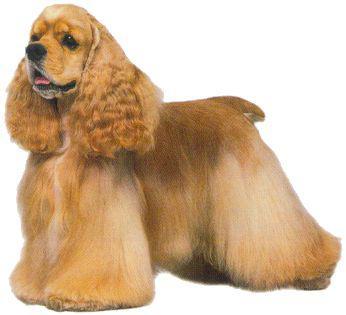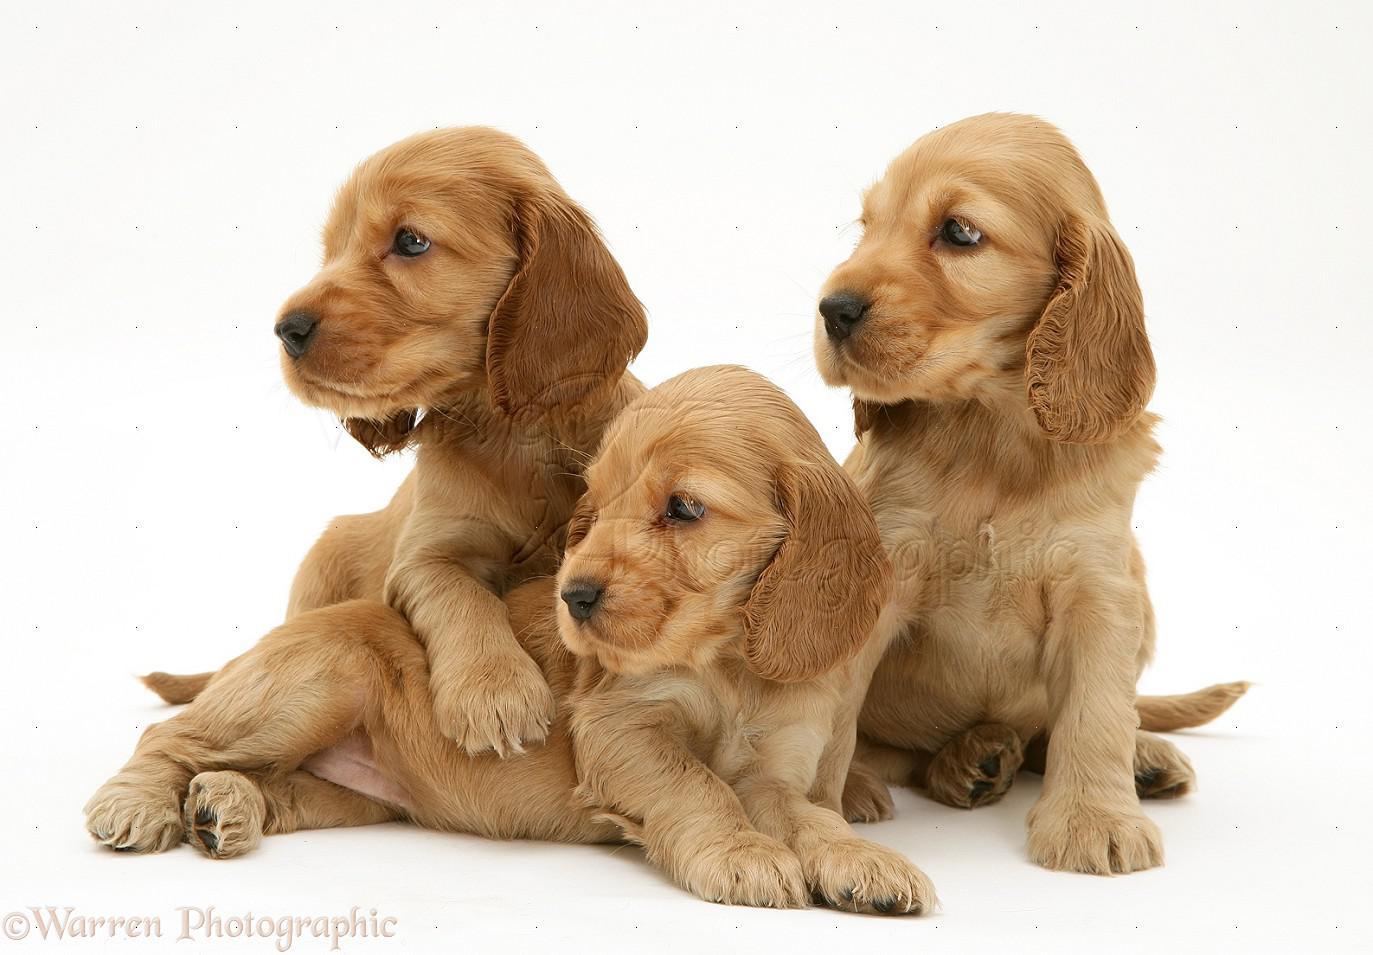The first image is the image on the left, the second image is the image on the right. For the images shown, is this caption "The right image contains exactly three dogs." true? Answer yes or no. Yes. The first image is the image on the left, the second image is the image on the right. Evaluate the accuracy of this statement regarding the images: "There are no more than 3 dogs.". Is it true? Answer yes or no. No. 